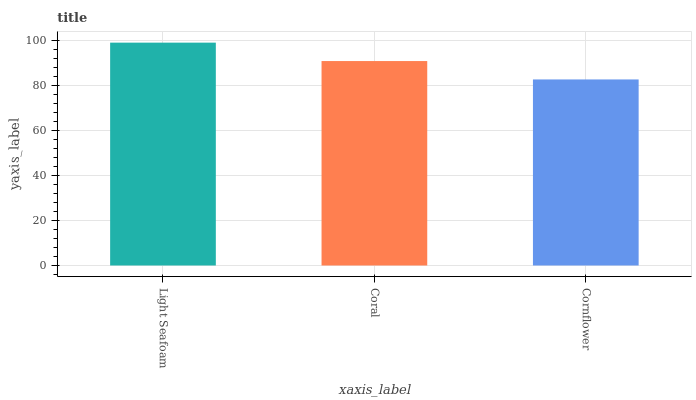Is Cornflower the minimum?
Answer yes or no. Yes. Is Light Seafoam the maximum?
Answer yes or no. Yes. Is Coral the minimum?
Answer yes or no. No. Is Coral the maximum?
Answer yes or no. No. Is Light Seafoam greater than Coral?
Answer yes or no. Yes. Is Coral less than Light Seafoam?
Answer yes or no. Yes. Is Coral greater than Light Seafoam?
Answer yes or no. No. Is Light Seafoam less than Coral?
Answer yes or no. No. Is Coral the high median?
Answer yes or no. Yes. Is Coral the low median?
Answer yes or no. Yes. Is Light Seafoam the high median?
Answer yes or no. No. Is Cornflower the low median?
Answer yes or no. No. 